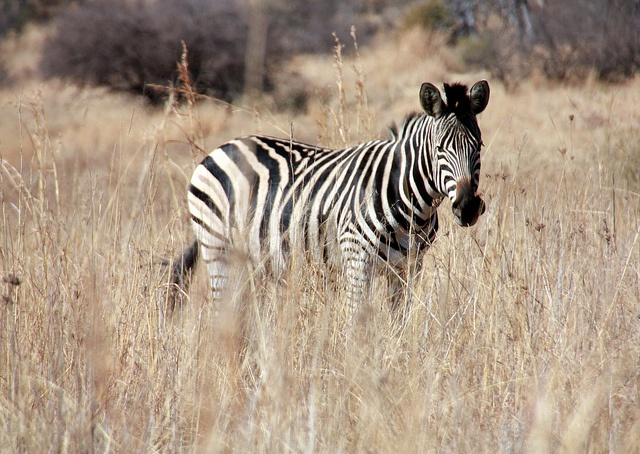Describe the objects in this image and their specific colors. I can see a zebra in black, lightgray, darkgray, and tan tones in this image. 